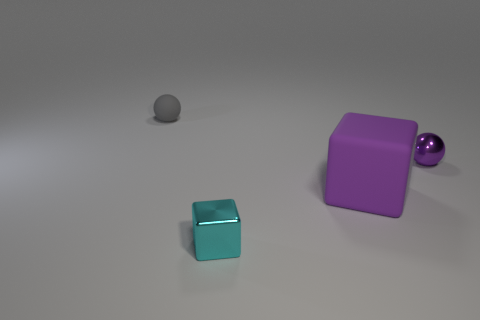There is a small ball that is the same color as the large matte block; what material is it? While the small ball shares the same color as the large matte block, suggesting they might be made of similar materials, the actual material cannot be definitively determined solely based on color. Factors like texture, reflection, and known properties of materials in our physical world would need to be considered to make an informed guess. 